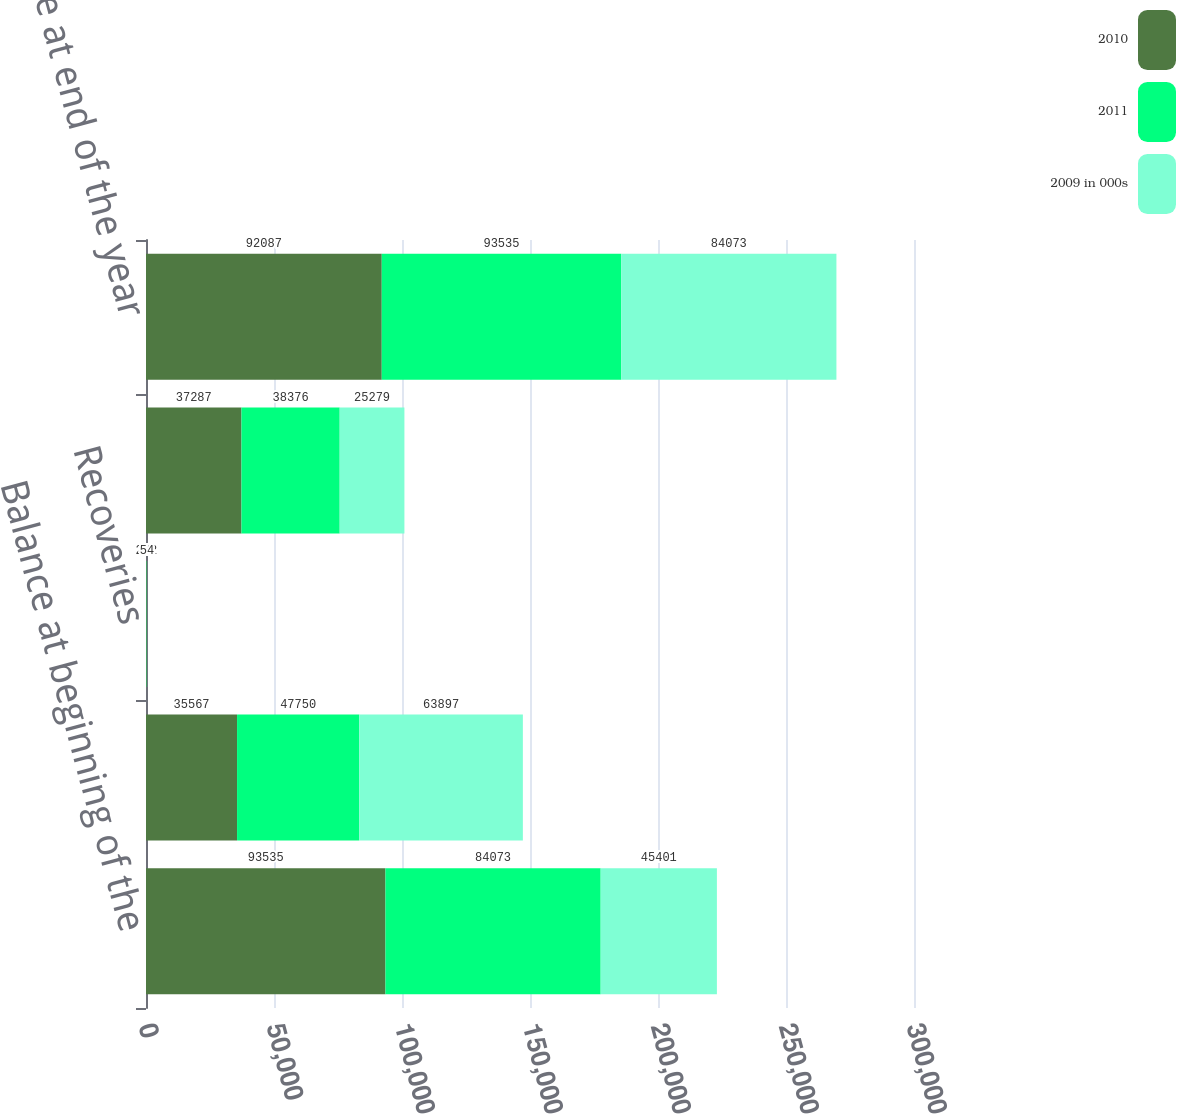<chart> <loc_0><loc_0><loc_500><loc_500><stacked_bar_chart><ecel><fcel>Balance at beginning of the<fcel>Provision<fcel>Recoveries<fcel>Charge-offs<fcel>Balance at end of the year<nl><fcel>2010<fcel>93535<fcel>35567<fcel>272<fcel>37287<fcel>92087<nl><fcel>2011<fcel>84073<fcel>47750<fcel>88<fcel>38376<fcel>93535<nl><fcel>2009 in 000s<fcel>45401<fcel>63897<fcel>54<fcel>25279<fcel>84073<nl></chart> 